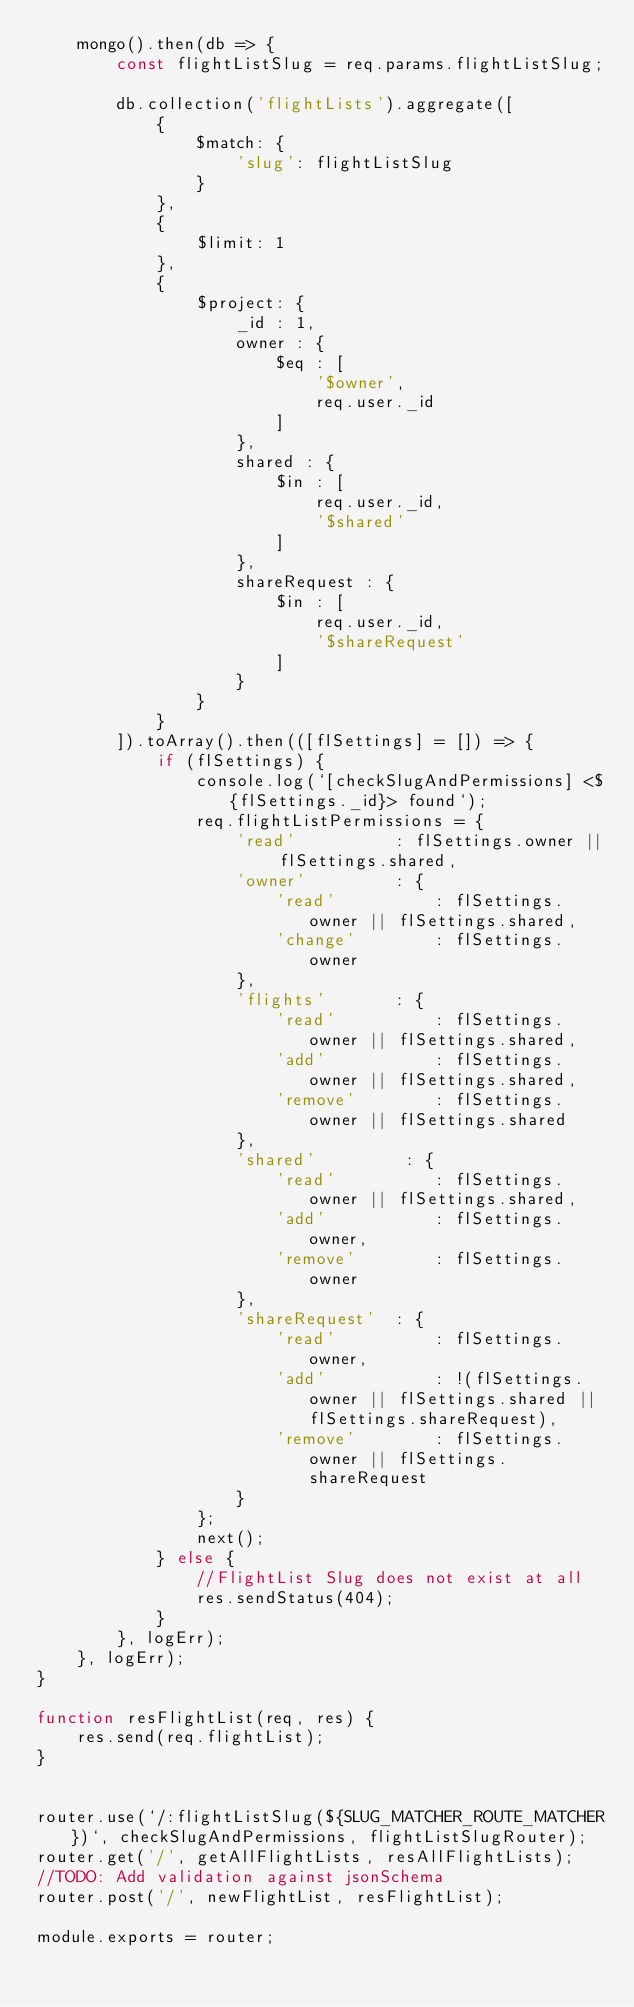Convert code to text. <code><loc_0><loc_0><loc_500><loc_500><_JavaScript_>    mongo().then(db => {
        const flightListSlug = req.params.flightListSlug;

        db.collection('flightLists').aggregate([
            {
                $match: {
                    'slug': flightListSlug
                }
            },
            {
                $limit: 1
            },
            {
                $project: {
                    _id : 1,
                    owner : {
                        $eq : [
                            '$owner',
                            req.user._id
                        ]
                    },
                    shared : {
                        $in : [
                            req.user._id,
                            '$shared'
                        ]
                    },
                    shareRequest : {
                        $in : [
                            req.user._id,
                            '$shareRequest'
                        ]
                    }
                }   
            }
        ]).toArray().then(([flSettings] = []) => {
            if (flSettings) {
                console.log(`[checkSlugAndPermissions] <${flSettings._id}> found`);
                req.flightListPermissions = {
                    'read'          : flSettings.owner || flSettings.shared,
                    'owner'         : {
                        'read'          : flSettings.owner || flSettings.shared,
                        'change'        : flSettings.owner
                    },
                    'flights'       : {
                        'read'          : flSettings.owner || flSettings.shared,
                        'add'           : flSettings.owner || flSettings.shared,
                        'remove'        : flSettings.owner || flSettings.shared
                    },
                    'shared'         : {
                        'read'          : flSettings.owner || flSettings.shared,
                        'add'           : flSettings.owner,
                        'remove'        : flSettings.owner
                    },
                    'shareRequest'  : {
                        'read'          : flSettings.owner,
                        'add'           : !(flSettings.owner || flSettings.shared || flSettings.shareRequest),
                        'remove'        : flSettings.owner || flSettings.shareRequest
                    }
                };
                next();
            } else {
                //FlightList Slug does not exist at all
                res.sendStatus(404);
            }
        }, logErr);
    }, logErr);
}

function resFlightList(req, res) {
    res.send(req.flightList);
}


router.use(`/:flightListSlug(${SLUG_MATCHER_ROUTE_MATCHER})`, checkSlugAndPermissions, flightListSlugRouter);
router.get('/', getAllFlightLists, resAllFlightLists);
//TODO: Add validation against jsonSchema
router.post('/', newFlightList, resFlightList);

module.exports = router;</code> 